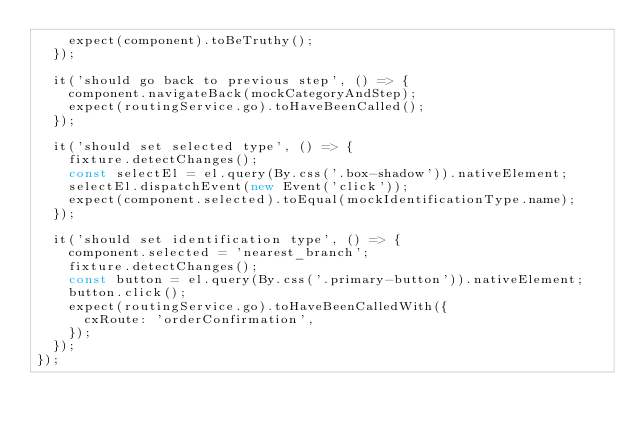Convert code to text. <code><loc_0><loc_0><loc_500><loc_500><_TypeScript_>    expect(component).toBeTruthy();
  });

  it('should go back to previous step', () => {
    component.navigateBack(mockCategoryAndStep);
    expect(routingService.go).toHaveBeenCalled();
  });

  it('should set selected type', () => {
    fixture.detectChanges();
    const selectEl = el.query(By.css('.box-shadow')).nativeElement;
    selectEl.dispatchEvent(new Event('click'));
    expect(component.selected).toEqual(mockIdentificationType.name);
  });

  it('should set identification type', () => {
    component.selected = 'nearest_branch';
    fixture.detectChanges();
    const button = el.query(By.css('.primary-button')).nativeElement;
    button.click();
    expect(routingService.go).toHaveBeenCalledWith({
      cxRoute: 'orderConfirmation',
    });
  });
});
</code> 